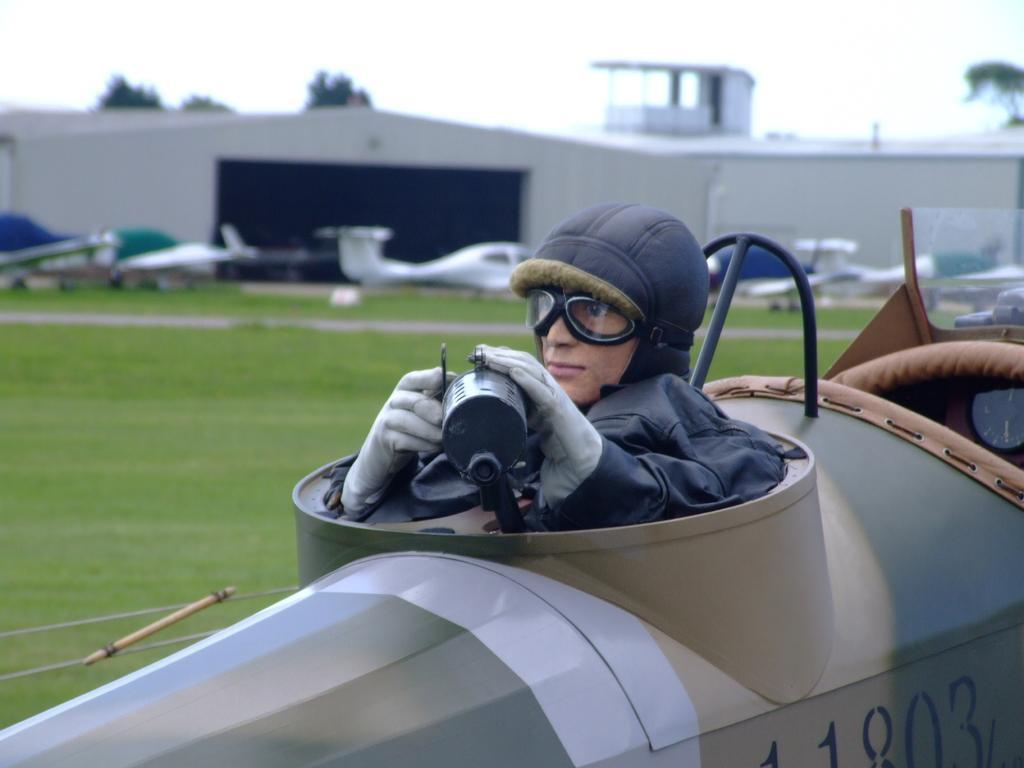Please provide a concise description of this image. In this image there are planes, a person, shed, tree, grass, sky and objects. A person wore goggles and holding an object. In the background of the image it is blurry.  